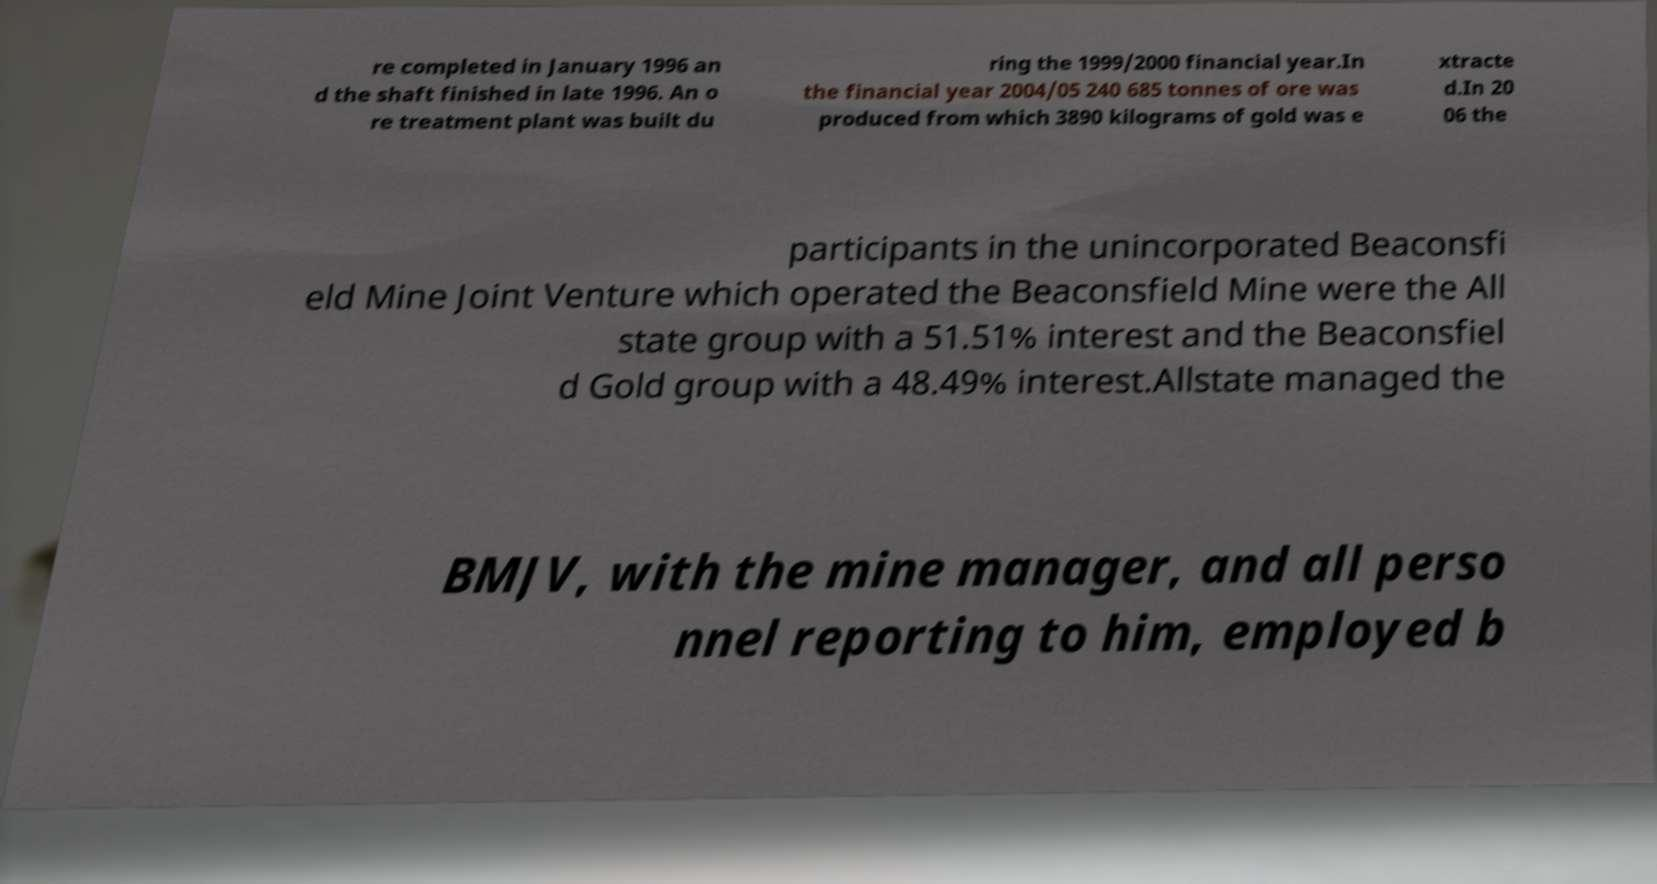Can you read and provide the text displayed in the image?This photo seems to have some interesting text. Can you extract and type it out for me? re completed in January 1996 an d the shaft finished in late 1996. An o re treatment plant was built du ring the 1999/2000 financial year.In the financial year 2004/05 240 685 tonnes of ore was produced from which 3890 kilograms of gold was e xtracte d.In 20 06 the participants in the unincorporated Beaconsfi eld Mine Joint Venture which operated the Beaconsfield Mine were the All state group with a 51.51% interest and the Beaconsfiel d Gold group with a 48.49% interest.Allstate managed the BMJV, with the mine manager, and all perso nnel reporting to him, employed b 